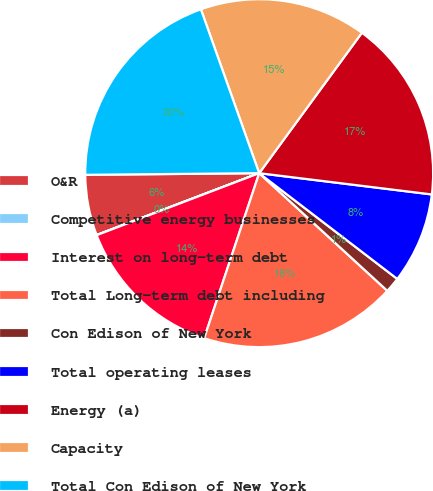Convert chart to OTSL. <chart><loc_0><loc_0><loc_500><loc_500><pie_chart><fcel>O&R<fcel>Competitive energy businesses<fcel>Interest on long-term debt<fcel>Total Long-term debt including<fcel>Con Edison of New York<fcel>Total operating leases<fcel>Energy (a)<fcel>Capacity<fcel>Total Con Edison of New York<nl><fcel>5.64%<fcel>0.01%<fcel>14.08%<fcel>18.3%<fcel>1.42%<fcel>8.45%<fcel>16.9%<fcel>15.49%<fcel>19.71%<nl></chart> 